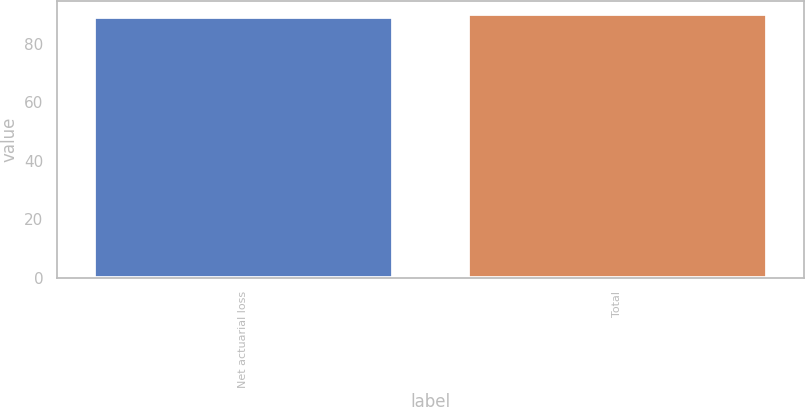Convert chart. <chart><loc_0><loc_0><loc_500><loc_500><bar_chart><fcel>Net actuarial loss<fcel>Total<nl><fcel>89<fcel>90<nl></chart> 